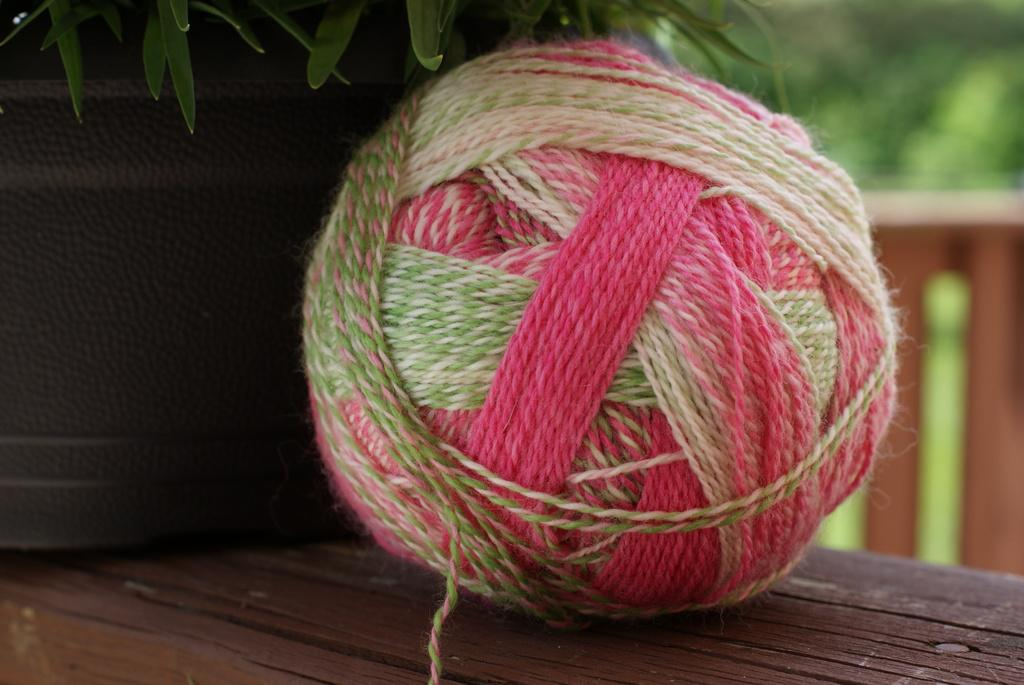What is placed on the wooden table in the image? There is a woolen thread ball on a wooden table. What is located near the woolen thread ball? There is a plant near the woolen thread ball. What can be seen in the background of the image? There appears to be a fence in the background. What is behind the fence in the image? The fence is in front of a garden. What type of banana is hanging from the woolen thread ball in the image? There is no banana present in the image; it features a woolen thread ball and a plant. Is there a scarf draped over the fence in the image? There is no scarf present in the image; it only shows a fence and a garden. 